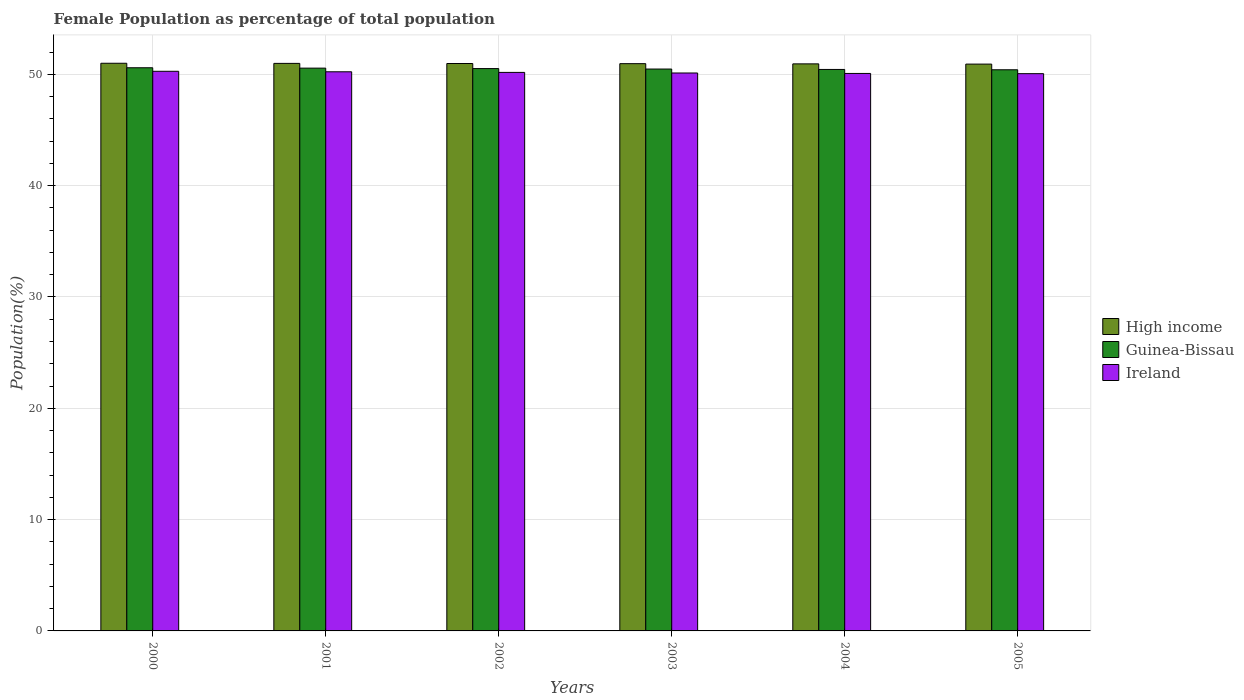How many different coloured bars are there?
Give a very brief answer. 3. How many bars are there on the 3rd tick from the left?
Ensure brevity in your answer.  3. What is the female population in in Ireland in 2001?
Your response must be concise. 50.22. Across all years, what is the maximum female population in in Guinea-Bissau?
Ensure brevity in your answer.  50.59. Across all years, what is the minimum female population in in High income?
Your answer should be very brief. 50.91. In which year was the female population in in High income maximum?
Keep it short and to the point. 2000. In which year was the female population in in High income minimum?
Make the answer very short. 2005. What is the total female population in in High income in the graph?
Ensure brevity in your answer.  305.74. What is the difference between the female population in in Ireland in 2001 and that in 2005?
Your answer should be very brief. 0.17. What is the difference between the female population in in Ireland in 2005 and the female population in in High income in 2004?
Keep it short and to the point. -0.88. What is the average female population in in Ireland per year?
Ensure brevity in your answer.  50.15. In the year 2003, what is the difference between the female population in in High income and female population in in Guinea-Bissau?
Your answer should be compact. 0.48. What is the ratio of the female population in in Guinea-Bissau in 2002 to that in 2005?
Ensure brevity in your answer.  1. Is the female population in in Ireland in 2000 less than that in 2003?
Keep it short and to the point. No. What is the difference between the highest and the second highest female population in in Ireland?
Your response must be concise. 0.04. What is the difference between the highest and the lowest female population in in Ireland?
Your answer should be very brief. 0.21. In how many years, is the female population in in Ireland greater than the average female population in in Ireland taken over all years?
Offer a very short reply. 3. What does the 3rd bar from the left in 2000 represents?
Ensure brevity in your answer.  Ireland. What does the 3rd bar from the right in 2003 represents?
Make the answer very short. High income. Is it the case that in every year, the sum of the female population in in Guinea-Bissau and female population in in High income is greater than the female population in in Ireland?
Your response must be concise. Yes. Does the graph contain any zero values?
Offer a terse response. No. Where does the legend appear in the graph?
Provide a succinct answer. Center right. How are the legend labels stacked?
Your answer should be compact. Vertical. What is the title of the graph?
Provide a short and direct response. Female Population as percentage of total population. What is the label or title of the X-axis?
Your response must be concise. Years. What is the label or title of the Y-axis?
Give a very brief answer. Population(%). What is the Population(%) in High income in 2000?
Offer a very short reply. 50.99. What is the Population(%) in Guinea-Bissau in 2000?
Your answer should be very brief. 50.59. What is the Population(%) of Ireland in 2000?
Your response must be concise. 50.27. What is the Population(%) of High income in 2001?
Ensure brevity in your answer.  50.98. What is the Population(%) of Guinea-Bissau in 2001?
Provide a short and direct response. 50.55. What is the Population(%) in Ireland in 2001?
Your answer should be compact. 50.22. What is the Population(%) of High income in 2002?
Make the answer very short. 50.97. What is the Population(%) in Guinea-Bissau in 2002?
Give a very brief answer. 50.51. What is the Population(%) of Ireland in 2002?
Your answer should be compact. 50.17. What is the Population(%) of High income in 2003?
Your answer should be compact. 50.95. What is the Population(%) in Guinea-Bissau in 2003?
Keep it short and to the point. 50.47. What is the Population(%) of Ireland in 2003?
Offer a very short reply. 50.12. What is the Population(%) in High income in 2004?
Make the answer very short. 50.94. What is the Population(%) in Guinea-Bissau in 2004?
Ensure brevity in your answer.  50.43. What is the Population(%) of Ireland in 2004?
Your answer should be compact. 50.08. What is the Population(%) of High income in 2005?
Give a very brief answer. 50.91. What is the Population(%) in Guinea-Bissau in 2005?
Offer a terse response. 50.41. What is the Population(%) in Ireland in 2005?
Your answer should be very brief. 50.06. Across all years, what is the maximum Population(%) of High income?
Keep it short and to the point. 50.99. Across all years, what is the maximum Population(%) in Guinea-Bissau?
Provide a short and direct response. 50.59. Across all years, what is the maximum Population(%) of Ireland?
Keep it short and to the point. 50.27. Across all years, what is the minimum Population(%) in High income?
Offer a terse response. 50.91. Across all years, what is the minimum Population(%) in Guinea-Bissau?
Provide a short and direct response. 50.41. Across all years, what is the minimum Population(%) in Ireland?
Provide a succinct answer. 50.06. What is the total Population(%) in High income in the graph?
Provide a succinct answer. 305.74. What is the total Population(%) in Guinea-Bissau in the graph?
Keep it short and to the point. 302.96. What is the total Population(%) of Ireland in the graph?
Offer a very short reply. 300.91. What is the difference between the Population(%) of High income in 2000 and that in 2001?
Ensure brevity in your answer.  0.01. What is the difference between the Population(%) of Guinea-Bissau in 2000 and that in 2001?
Your answer should be very brief. 0.03. What is the difference between the Population(%) in Ireland in 2000 and that in 2001?
Make the answer very short. 0.04. What is the difference between the Population(%) of High income in 2000 and that in 2002?
Your response must be concise. 0.02. What is the difference between the Population(%) in Guinea-Bissau in 2000 and that in 2002?
Ensure brevity in your answer.  0.07. What is the difference between the Population(%) of Ireland in 2000 and that in 2002?
Offer a terse response. 0.1. What is the difference between the Population(%) of High income in 2000 and that in 2003?
Offer a terse response. 0.04. What is the difference between the Population(%) of Guinea-Bissau in 2000 and that in 2003?
Provide a succinct answer. 0.12. What is the difference between the Population(%) of Ireland in 2000 and that in 2003?
Keep it short and to the point. 0.15. What is the difference between the Population(%) of High income in 2000 and that in 2004?
Your answer should be very brief. 0.05. What is the difference between the Population(%) of Guinea-Bissau in 2000 and that in 2004?
Provide a short and direct response. 0.15. What is the difference between the Population(%) of Ireland in 2000 and that in 2004?
Keep it short and to the point. 0.19. What is the difference between the Population(%) of High income in 2000 and that in 2005?
Offer a terse response. 0.08. What is the difference between the Population(%) of Guinea-Bissau in 2000 and that in 2005?
Give a very brief answer. 0.18. What is the difference between the Population(%) in Ireland in 2000 and that in 2005?
Give a very brief answer. 0.21. What is the difference between the Population(%) of High income in 2001 and that in 2002?
Offer a very short reply. 0.01. What is the difference between the Population(%) of Guinea-Bissau in 2001 and that in 2002?
Keep it short and to the point. 0.04. What is the difference between the Population(%) in Ireland in 2001 and that in 2002?
Your answer should be very brief. 0.05. What is the difference between the Population(%) of High income in 2001 and that in 2003?
Give a very brief answer. 0.03. What is the difference between the Population(%) in Guinea-Bissau in 2001 and that in 2003?
Provide a succinct answer. 0.08. What is the difference between the Population(%) in Ireland in 2001 and that in 2003?
Provide a succinct answer. 0.11. What is the difference between the Population(%) in High income in 2001 and that in 2004?
Offer a very short reply. 0.04. What is the difference between the Population(%) of Guinea-Bissau in 2001 and that in 2004?
Provide a succinct answer. 0.12. What is the difference between the Population(%) in Ireland in 2001 and that in 2004?
Your answer should be very brief. 0.15. What is the difference between the Population(%) of High income in 2001 and that in 2005?
Offer a very short reply. 0.07. What is the difference between the Population(%) in Guinea-Bissau in 2001 and that in 2005?
Your answer should be compact. 0.15. What is the difference between the Population(%) in Ireland in 2001 and that in 2005?
Your answer should be very brief. 0.17. What is the difference between the Population(%) of High income in 2002 and that in 2003?
Give a very brief answer. 0.01. What is the difference between the Population(%) in Guinea-Bissau in 2002 and that in 2003?
Give a very brief answer. 0.04. What is the difference between the Population(%) of Ireland in 2002 and that in 2003?
Your response must be concise. 0.05. What is the difference between the Population(%) of High income in 2002 and that in 2004?
Give a very brief answer. 0.03. What is the difference between the Population(%) in Guinea-Bissau in 2002 and that in 2004?
Your response must be concise. 0.08. What is the difference between the Population(%) of Ireland in 2002 and that in 2004?
Provide a short and direct response. 0.09. What is the difference between the Population(%) in High income in 2002 and that in 2005?
Make the answer very short. 0.05. What is the difference between the Population(%) in Guinea-Bissau in 2002 and that in 2005?
Your response must be concise. 0.11. What is the difference between the Population(%) in Ireland in 2002 and that in 2005?
Your answer should be very brief. 0.11. What is the difference between the Population(%) of High income in 2003 and that in 2004?
Your response must be concise. 0.02. What is the difference between the Population(%) of Guinea-Bissau in 2003 and that in 2004?
Your answer should be compact. 0.04. What is the difference between the Population(%) in Ireland in 2003 and that in 2004?
Keep it short and to the point. 0.04. What is the difference between the Population(%) in High income in 2003 and that in 2005?
Keep it short and to the point. 0.04. What is the difference between the Population(%) of Guinea-Bissau in 2003 and that in 2005?
Provide a short and direct response. 0.07. What is the difference between the Population(%) in Ireland in 2003 and that in 2005?
Provide a short and direct response. 0.06. What is the difference between the Population(%) of High income in 2004 and that in 2005?
Ensure brevity in your answer.  0.02. What is the difference between the Population(%) in Guinea-Bissau in 2004 and that in 2005?
Ensure brevity in your answer.  0.03. What is the difference between the Population(%) in Ireland in 2004 and that in 2005?
Give a very brief answer. 0.02. What is the difference between the Population(%) of High income in 2000 and the Population(%) of Guinea-Bissau in 2001?
Your answer should be very brief. 0.44. What is the difference between the Population(%) of High income in 2000 and the Population(%) of Ireland in 2001?
Ensure brevity in your answer.  0.77. What is the difference between the Population(%) of Guinea-Bissau in 2000 and the Population(%) of Ireland in 2001?
Ensure brevity in your answer.  0.36. What is the difference between the Population(%) of High income in 2000 and the Population(%) of Guinea-Bissau in 2002?
Give a very brief answer. 0.48. What is the difference between the Population(%) of High income in 2000 and the Population(%) of Ireland in 2002?
Offer a very short reply. 0.82. What is the difference between the Population(%) of Guinea-Bissau in 2000 and the Population(%) of Ireland in 2002?
Ensure brevity in your answer.  0.42. What is the difference between the Population(%) in High income in 2000 and the Population(%) in Guinea-Bissau in 2003?
Your answer should be very brief. 0.52. What is the difference between the Population(%) of Guinea-Bissau in 2000 and the Population(%) of Ireland in 2003?
Your response must be concise. 0.47. What is the difference between the Population(%) of High income in 2000 and the Population(%) of Guinea-Bissau in 2004?
Keep it short and to the point. 0.56. What is the difference between the Population(%) in High income in 2000 and the Population(%) in Ireland in 2004?
Keep it short and to the point. 0.92. What is the difference between the Population(%) in Guinea-Bissau in 2000 and the Population(%) in Ireland in 2004?
Ensure brevity in your answer.  0.51. What is the difference between the Population(%) in High income in 2000 and the Population(%) in Guinea-Bissau in 2005?
Make the answer very short. 0.58. What is the difference between the Population(%) in High income in 2000 and the Population(%) in Ireland in 2005?
Ensure brevity in your answer.  0.93. What is the difference between the Population(%) in Guinea-Bissau in 2000 and the Population(%) in Ireland in 2005?
Your response must be concise. 0.53. What is the difference between the Population(%) in High income in 2001 and the Population(%) in Guinea-Bissau in 2002?
Your answer should be compact. 0.47. What is the difference between the Population(%) of High income in 2001 and the Population(%) of Ireland in 2002?
Provide a succinct answer. 0.81. What is the difference between the Population(%) in Guinea-Bissau in 2001 and the Population(%) in Ireland in 2002?
Give a very brief answer. 0.38. What is the difference between the Population(%) in High income in 2001 and the Population(%) in Guinea-Bissau in 2003?
Offer a very short reply. 0.51. What is the difference between the Population(%) of High income in 2001 and the Population(%) of Ireland in 2003?
Offer a very short reply. 0.86. What is the difference between the Population(%) of Guinea-Bissau in 2001 and the Population(%) of Ireland in 2003?
Your response must be concise. 0.44. What is the difference between the Population(%) in High income in 2001 and the Population(%) in Guinea-Bissau in 2004?
Provide a short and direct response. 0.55. What is the difference between the Population(%) of High income in 2001 and the Population(%) of Ireland in 2004?
Offer a terse response. 0.91. What is the difference between the Population(%) of Guinea-Bissau in 2001 and the Population(%) of Ireland in 2004?
Your response must be concise. 0.48. What is the difference between the Population(%) of High income in 2001 and the Population(%) of Guinea-Bissau in 2005?
Make the answer very short. 0.57. What is the difference between the Population(%) in High income in 2001 and the Population(%) in Ireland in 2005?
Your answer should be very brief. 0.92. What is the difference between the Population(%) in Guinea-Bissau in 2001 and the Population(%) in Ireland in 2005?
Your answer should be compact. 0.5. What is the difference between the Population(%) in High income in 2002 and the Population(%) in Guinea-Bissau in 2003?
Offer a terse response. 0.5. What is the difference between the Population(%) of High income in 2002 and the Population(%) of Ireland in 2003?
Offer a terse response. 0.85. What is the difference between the Population(%) in Guinea-Bissau in 2002 and the Population(%) in Ireland in 2003?
Make the answer very short. 0.4. What is the difference between the Population(%) of High income in 2002 and the Population(%) of Guinea-Bissau in 2004?
Your answer should be compact. 0.53. What is the difference between the Population(%) in High income in 2002 and the Population(%) in Ireland in 2004?
Offer a terse response. 0.89. What is the difference between the Population(%) of Guinea-Bissau in 2002 and the Population(%) of Ireland in 2004?
Provide a succinct answer. 0.44. What is the difference between the Population(%) of High income in 2002 and the Population(%) of Guinea-Bissau in 2005?
Your answer should be compact. 0.56. What is the difference between the Population(%) in High income in 2002 and the Population(%) in Ireland in 2005?
Offer a terse response. 0.91. What is the difference between the Population(%) in Guinea-Bissau in 2002 and the Population(%) in Ireland in 2005?
Your answer should be compact. 0.46. What is the difference between the Population(%) in High income in 2003 and the Population(%) in Guinea-Bissau in 2004?
Your answer should be compact. 0.52. What is the difference between the Population(%) of High income in 2003 and the Population(%) of Ireland in 2004?
Keep it short and to the point. 0.88. What is the difference between the Population(%) in Guinea-Bissau in 2003 and the Population(%) in Ireland in 2004?
Offer a terse response. 0.4. What is the difference between the Population(%) in High income in 2003 and the Population(%) in Guinea-Bissau in 2005?
Make the answer very short. 0.55. What is the difference between the Population(%) of High income in 2003 and the Population(%) of Ireland in 2005?
Your answer should be compact. 0.9. What is the difference between the Population(%) of Guinea-Bissau in 2003 and the Population(%) of Ireland in 2005?
Make the answer very short. 0.42. What is the difference between the Population(%) of High income in 2004 and the Population(%) of Guinea-Bissau in 2005?
Ensure brevity in your answer.  0.53. What is the difference between the Population(%) in High income in 2004 and the Population(%) in Ireland in 2005?
Provide a succinct answer. 0.88. What is the difference between the Population(%) in Guinea-Bissau in 2004 and the Population(%) in Ireland in 2005?
Ensure brevity in your answer.  0.38. What is the average Population(%) of High income per year?
Keep it short and to the point. 50.96. What is the average Population(%) of Guinea-Bissau per year?
Provide a succinct answer. 50.49. What is the average Population(%) in Ireland per year?
Offer a very short reply. 50.15. In the year 2000, what is the difference between the Population(%) of High income and Population(%) of Guinea-Bissau?
Your response must be concise. 0.4. In the year 2000, what is the difference between the Population(%) in High income and Population(%) in Ireland?
Provide a succinct answer. 0.72. In the year 2000, what is the difference between the Population(%) of Guinea-Bissau and Population(%) of Ireland?
Your response must be concise. 0.32. In the year 2001, what is the difference between the Population(%) in High income and Population(%) in Guinea-Bissau?
Your answer should be compact. 0.43. In the year 2001, what is the difference between the Population(%) of High income and Population(%) of Ireland?
Provide a succinct answer. 0.76. In the year 2001, what is the difference between the Population(%) in Guinea-Bissau and Population(%) in Ireland?
Provide a succinct answer. 0.33. In the year 2002, what is the difference between the Population(%) in High income and Population(%) in Guinea-Bissau?
Provide a short and direct response. 0.46. In the year 2002, what is the difference between the Population(%) in High income and Population(%) in Ireland?
Your answer should be compact. 0.8. In the year 2002, what is the difference between the Population(%) of Guinea-Bissau and Population(%) of Ireland?
Give a very brief answer. 0.34. In the year 2003, what is the difference between the Population(%) in High income and Population(%) in Guinea-Bissau?
Provide a short and direct response. 0.48. In the year 2003, what is the difference between the Population(%) in High income and Population(%) in Ireland?
Provide a short and direct response. 0.84. In the year 2003, what is the difference between the Population(%) of Guinea-Bissau and Population(%) of Ireland?
Keep it short and to the point. 0.36. In the year 2004, what is the difference between the Population(%) in High income and Population(%) in Guinea-Bissau?
Make the answer very short. 0.5. In the year 2004, what is the difference between the Population(%) in High income and Population(%) in Ireland?
Your answer should be compact. 0.86. In the year 2004, what is the difference between the Population(%) of Guinea-Bissau and Population(%) of Ireland?
Keep it short and to the point. 0.36. In the year 2005, what is the difference between the Population(%) in High income and Population(%) in Guinea-Bissau?
Your answer should be compact. 0.51. In the year 2005, what is the difference between the Population(%) of High income and Population(%) of Ireland?
Provide a succinct answer. 0.86. In the year 2005, what is the difference between the Population(%) of Guinea-Bissau and Population(%) of Ireland?
Keep it short and to the point. 0.35. What is the ratio of the Population(%) of Guinea-Bissau in 2000 to that in 2001?
Ensure brevity in your answer.  1. What is the ratio of the Population(%) in Ireland in 2000 to that in 2001?
Provide a short and direct response. 1. What is the ratio of the Population(%) of High income in 2000 to that in 2002?
Provide a short and direct response. 1. What is the ratio of the Population(%) of Ireland in 2000 to that in 2003?
Offer a terse response. 1. What is the ratio of the Population(%) in High income in 2000 to that in 2004?
Ensure brevity in your answer.  1. What is the ratio of the Population(%) in Ireland in 2001 to that in 2002?
Ensure brevity in your answer.  1. What is the ratio of the Population(%) of High income in 2001 to that in 2004?
Your answer should be very brief. 1. What is the ratio of the Population(%) of Ireland in 2001 to that in 2005?
Keep it short and to the point. 1. What is the ratio of the Population(%) of Guinea-Bissau in 2002 to that in 2004?
Provide a short and direct response. 1. What is the ratio of the Population(%) of Guinea-Bissau in 2003 to that in 2004?
Your response must be concise. 1. What is the ratio of the Population(%) in Ireland in 2003 to that in 2004?
Keep it short and to the point. 1. What is the ratio of the Population(%) of Guinea-Bissau in 2003 to that in 2005?
Give a very brief answer. 1. What is the ratio of the Population(%) in High income in 2004 to that in 2005?
Offer a terse response. 1. What is the ratio of the Population(%) in Guinea-Bissau in 2004 to that in 2005?
Your answer should be very brief. 1. What is the difference between the highest and the second highest Population(%) in High income?
Offer a terse response. 0.01. What is the difference between the highest and the second highest Population(%) of Guinea-Bissau?
Ensure brevity in your answer.  0.03. What is the difference between the highest and the second highest Population(%) of Ireland?
Provide a short and direct response. 0.04. What is the difference between the highest and the lowest Population(%) of High income?
Offer a very short reply. 0.08. What is the difference between the highest and the lowest Population(%) of Guinea-Bissau?
Make the answer very short. 0.18. What is the difference between the highest and the lowest Population(%) of Ireland?
Offer a very short reply. 0.21. 